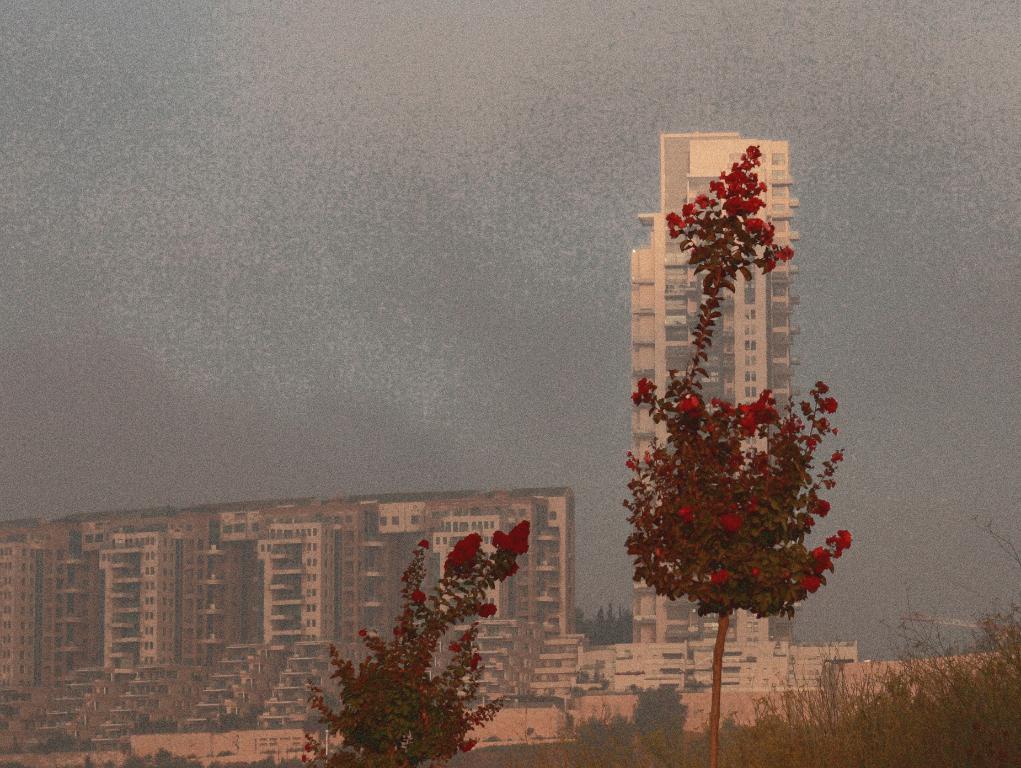Could you give a brief overview of what you see in this image? In the foreground of the picture I can see the flowering plants. I can see the green grass on the bottom right side of the picture. In the background, I can see the buildings. There are clouds in the sky. 